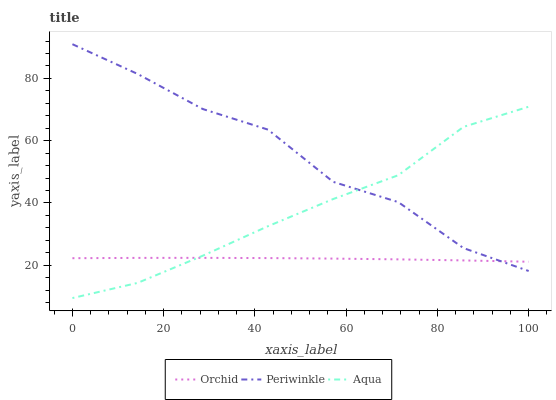Does Orchid have the minimum area under the curve?
Answer yes or no. Yes. Does Periwinkle have the maximum area under the curve?
Answer yes or no. Yes. Does Periwinkle have the minimum area under the curve?
Answer yes or no. No. Does Orchid have the maximum area under the curve?
Answer yes or no. No. Is Orchid the smoothest?
Answer yes or no. Yes. Is Periwinkle the roughest?
Answer yes or no. Yes. Is Periwinkle the smoothest?
Answer yes or no. No. Is Orchid the roughest?
Answer yes or no. No. Does Aqua have the lowest value?
Answer yes or no. Yes. Does Periwinkle have the lowest value?
Answer yes or no. No. Does Periwinkle have the highest value?
Answer yes or no. Yes. Does Orchid have the highest value?
Answer yes or no. No. Does Orchid intersect Periwinkle?
Answer yes or no. Yes. Is Orchid less than Periwinkle?
Answer yes or no. No. Is Orchid greater than Periwinkle?
Answer yes or no. No. 